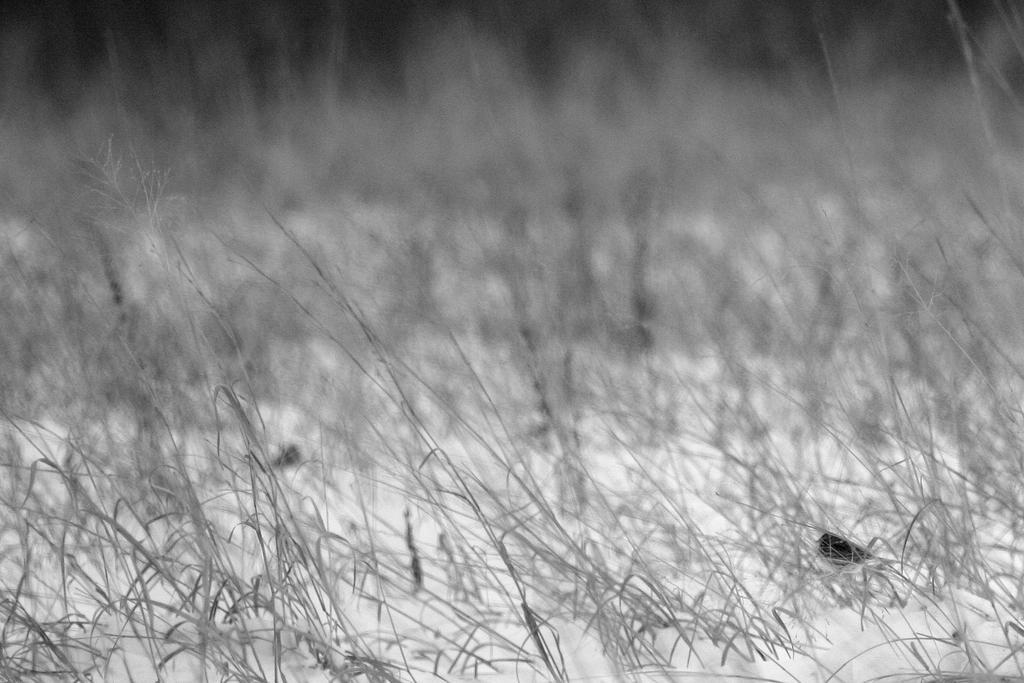How would you summarize this image in a sentence or two? This is a black and white image, in this image there is grass, in the background it is blurred. 